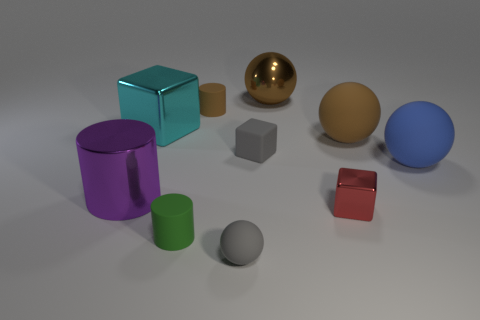Subtract all cylinders. How many objects are left? 7 Add 5 tiny brown matte cylinders. How many tiny brown matte cylinders are left? 6 Add 3 large blue things. How many large blue things exist? 4 Subtract 0 purple cubes. How many objects are left? 10 Subtract all yellow spheres. Subtract all cyan metallic objects. How many objects are left? 9 